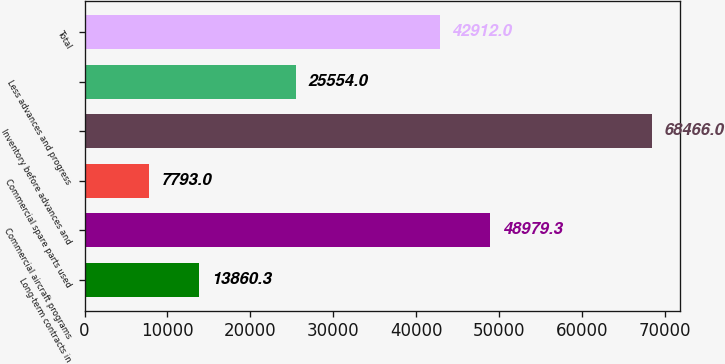Convert chart to OTSL. <chart><loc_0><loc_0><loc_500><loc_500><bar_chart><fcel>Long-term contracts in<fcel>Commercial aircraft programs<fcel>Commercial spare parts used<fcel>Inventory before advances and<fcel>Less advances and progress<fcel>Total<nl><fcel>13860.3<fcel>48979.3<fcel>7793<fcel>68466<fcel>25554<fcel>42912<nl></chart> 